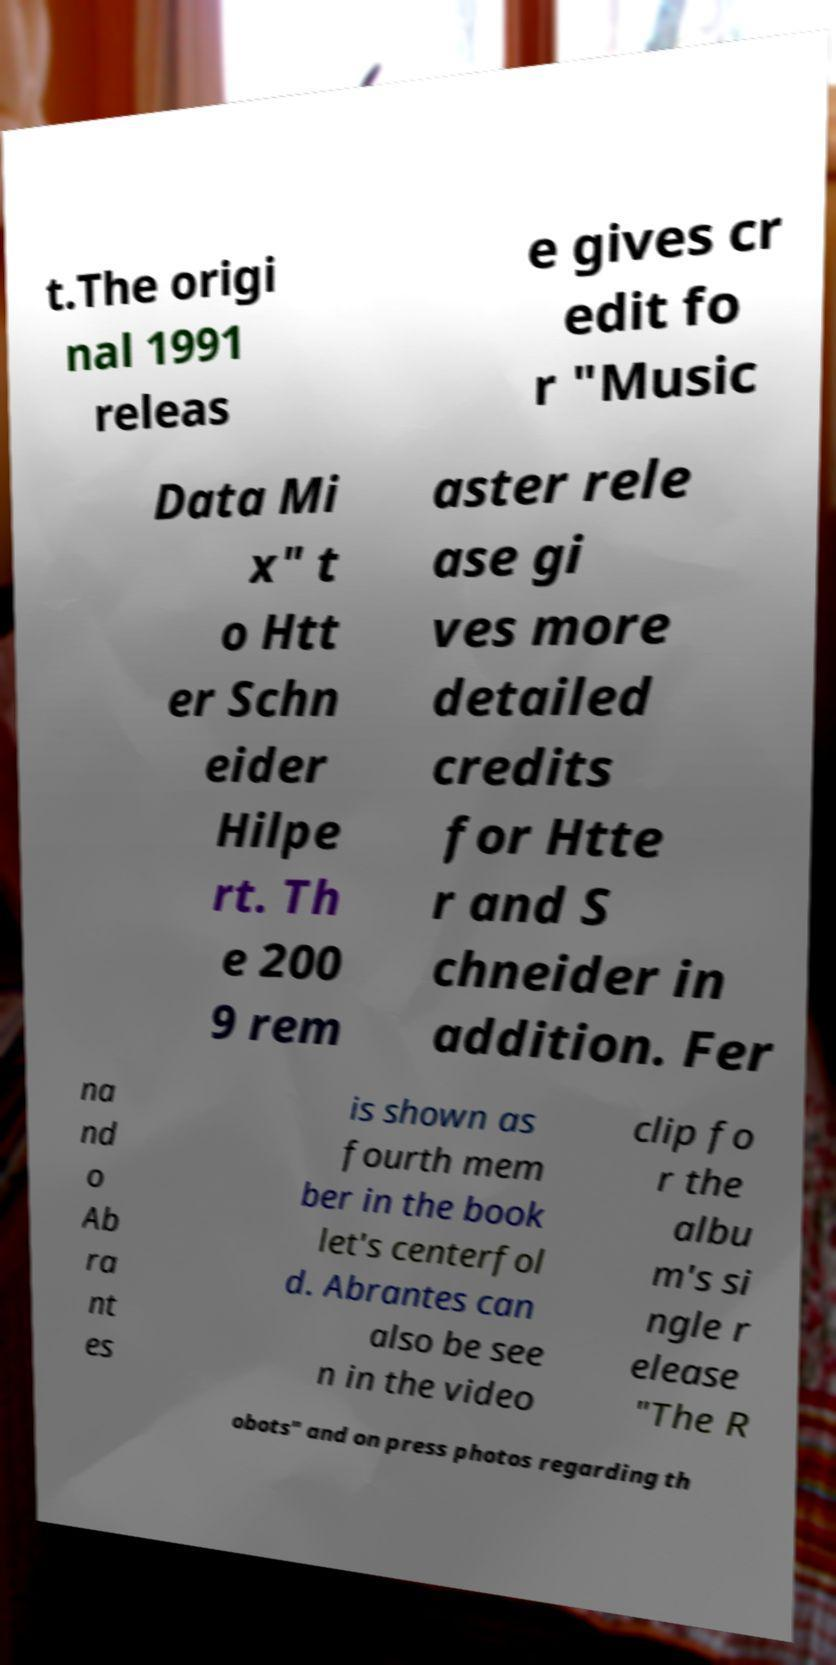There's text embedded in this image that I need extracted. Can you transcribe it verbatim? t.The origi nal 1991 releas e gives cr edit fo r "Music Data Mi x" t o Htt er Schn eider Hilpe rt. Th e 200 9 rem aster rele ase gi ves more detailed credits for Htte r and S chneider in addition. Fer na nd o Ab ra nt es is shown as fourth mem ber in the book let's centerfol d. Abrantes can also be see n in the video clip fo r the albu m's si ngle r elease "The R obots" and on press photos regarding th 